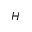<formula> <loc_0><loc_0><loc_500><loc_500>H</formula> 